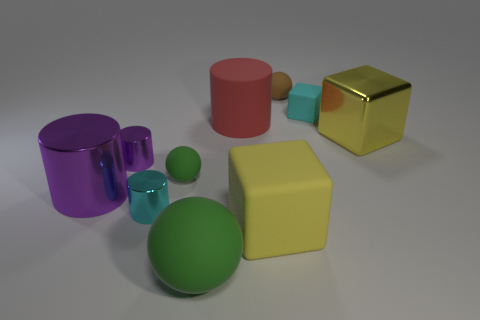What number of shiny objects are small blue blocks or big objects?
Make the answer very short. 2. There is a big cylinder on the left side of the small rubber object left of the big red matte cylinder; are there any green matte spheres behind it?
Give a very brief answer. Yes. The brown ball that is the same material as the large green ball is what size?
Offer a very short reply. Small. Are there any green rubber things on the right side of the tiny cyan shiny cylinder?
Your response must be concise. Yes. There is a matte ball on the right side of the large yellow matte cube; is there a brown sphere that is in front of it?
Ensure brevity in your answer.  No. There is a green ball in front of the cyan metal cylinder; is it the same size as the cyan object left of the small rubber block?
Keep it short and to the point. No. What number of tiny things are green rubber balls or red rubber cylinders?
Your answer should be compact. 1. What material is the large thing that is to the right of the tiny rubber ball that is to the right of the big rubber cylinder?
Your answer should be compact. Metal. What is the shape of the rubber object that is the same color as the large ball?
Your answer should be very brief. Sphere. Is there a cyan object made of the same material as the tiny green object?
Keep it short and to the point. Yes. 